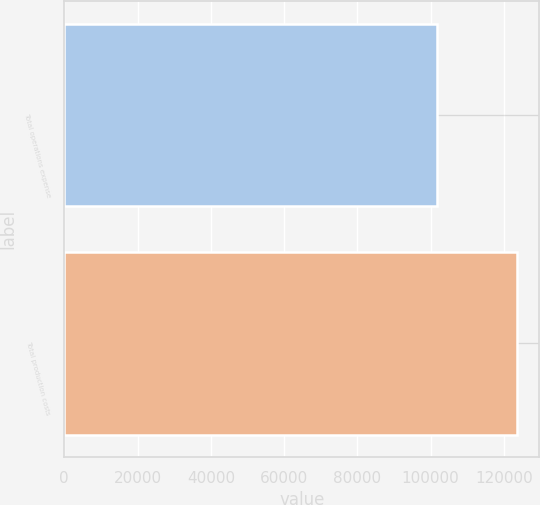Convert chart to OTSL. <chart><loc_0><loc_0><loc_500><loc_500><bar_chart><fcel>Total operations expense<fcel>Total production costs<nl><fcel>101648<fcel>123454<nl></chart> 